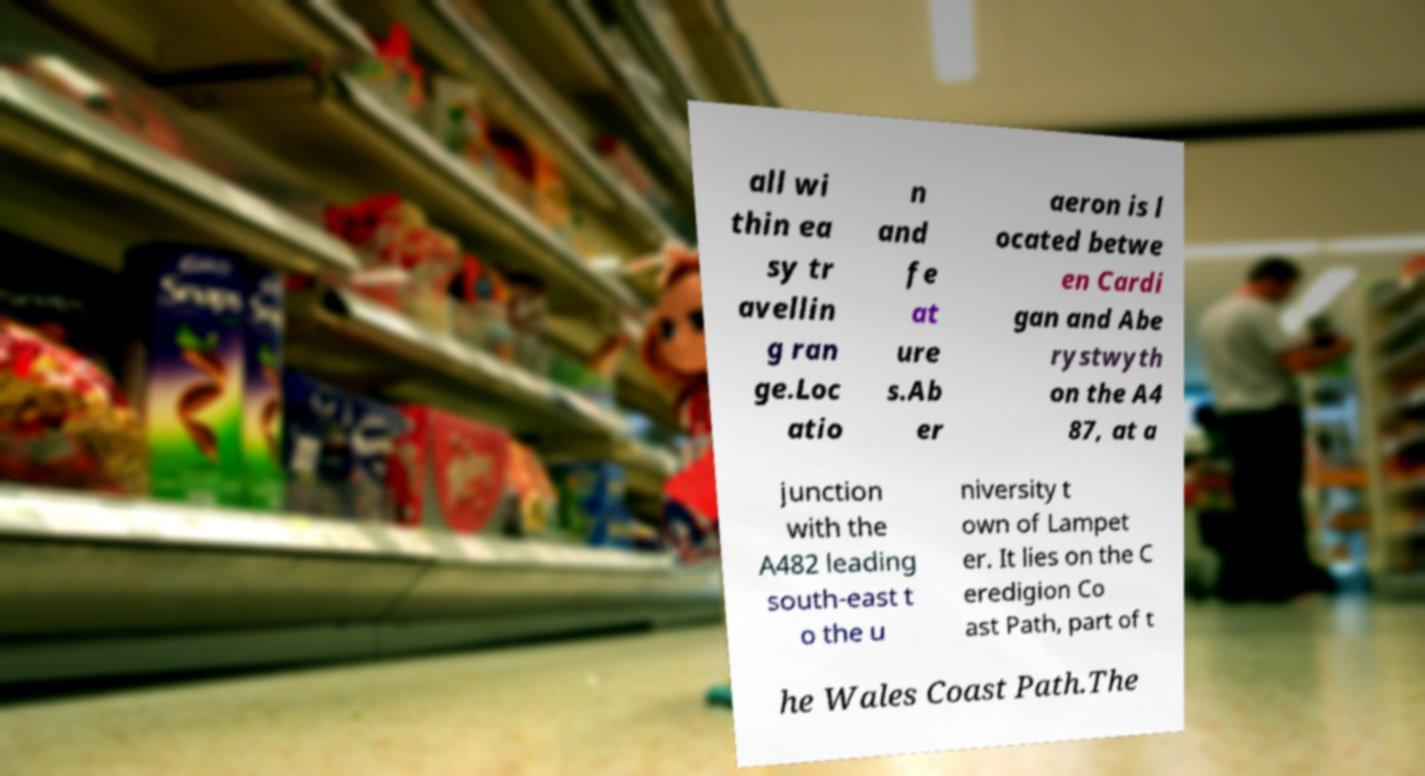For documentation purposes, I need the text within this image transcribed. Could you provide that? all wi thin ea sy tr avellin g ran ge.Loc atio n and fe at ure s.Ab er aeron is l ocated betwe en Cardi gan and Abe rystwyth on the A4 87, at a junction with the A482 leading south-east t o the u niversity t own of Lampet er. It lies on the C eredigion Co ast Path, part of t he Wales Coast Path.The 